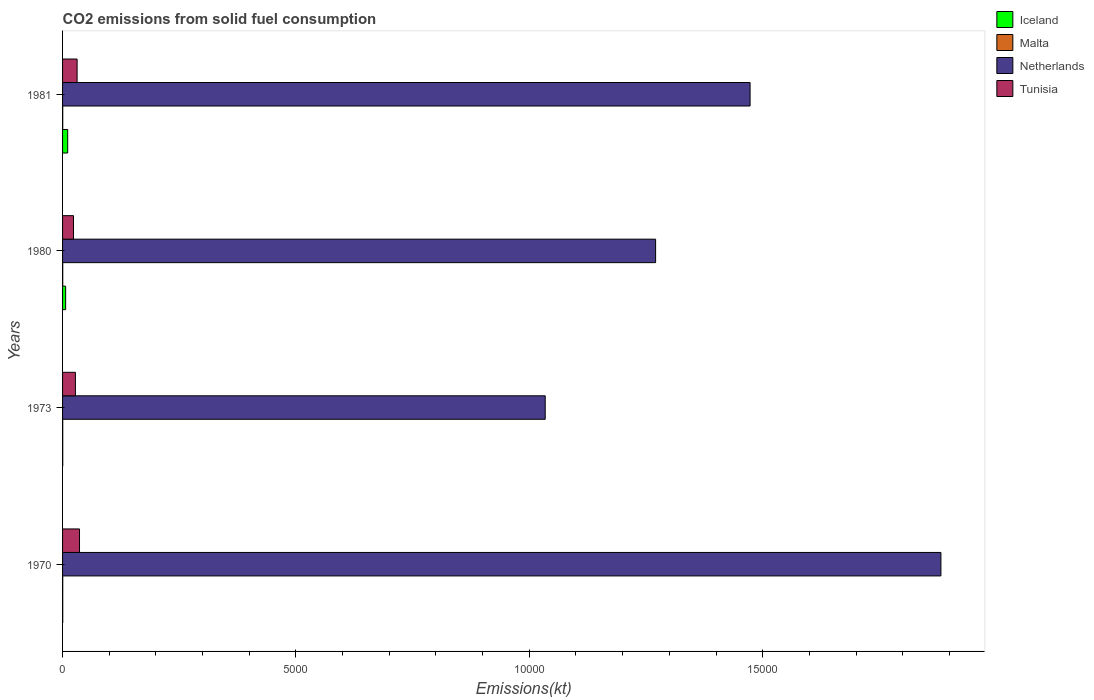How many different coloured bars are there?
Give a very brief answer. 4. Are the number of bars on each tick of the Y-axis equal?
Provide a short and direct response. Yes. How many bars are there on the 4th tick from the top?
Your answer should be very brief. 4. What is the label of the 4th group of bars from the top?
Your answer should be very brief. 1970. In how many cases, is the number of bars for a given year not equal to the number of legend labels?
Ensure brevity in your answer.  0. What is the amount of CO2 emitted in Netherlands in 1973?
Provide a succinct answer. 1.03e+04. Across all years, what is the maximum amount of CO2 emitted in Netherlands?
Make the answer very short. 1.88e+04. Across all years, what is the minimum amount of CO2 emitted in Tunisia?
Your answer should be compact. 234.69. What is the total amount of CO2 emitted in Netherlands in the graph?
Provide a short and direct response. 5.66e+04. What is the difference between the amount of CO2 emitted in Malta in 1970 and the amount of CO2 emitted in Netherlands in 1973?
Offer a very short reply. -1.03e+04. What is the average amount of CO2 emitted in Netherlands per year?
Provide a succinct answer. 1.41e+04. In the year 1980, what is the difference between the amount of CO2 emitted in Iceland and amount of CO2 emitted in Malta?
Provide a succinct answer. 62.34. In how many years, is the amount of CO2 emitted in Iceland greater than 7000 kt?
Provide a short and direct response. 0. Is the difference between the amount of CO2 emitted in Iceland in 1980 and 1981 greater than the difference between the amount of CO2 emitted in Malta in 1980 and 1981?
Offer a terse response. No. What is the difference between the highest and the second highest amount of CO2 emitted in Tunisia?
Ensure brevity in your answer.  51.34. What is the difference between the highest and the lowest amount of CO2 emitted in Netherlands?
Offer a very short reply. 8478.1. Is it the case that in every year, the sum of the amount of CO2 emitted in Netherlands and amount of CO2 emitted in Malta is greater than the sum of amount of CO2 emitted in Tunisia and amount of CO2 emitted in Iceland?
Your response must be concise. Yes. What does the 1st bar from the top in 1981 represents?
Keep it short and to the point. Tunisia. What does the 3rd bar from the bottom in 1980 represents?
Offer a very short reply. Netherlands. Is it the case that in every year, the sum of the amount of CO2 emitted in Iceland and amount of CO2 emitted in Malta is greater than the amount of CO2 emitted in Netherlands?
Offer a very short reply. No. How many bars are there?
Provide a succinct answer. 16. How many years are there in the graph?
Provide a short and direct response. 4. Are the values on the major ticks of X-axis written in scientific E-notation?
Your answer should be compact. No. Does the graph contain any zero values?
Your answer should be compact. No. How many legend labels are there?
Provide a short and direct response. 4. What is the title of the graph?
Ensure brevity in your answer.  CO2 emissions from solid fuel consumption. Does "Guinea-Bissau" appear as one of the legend labels in the graph?
Your answer should be very brief. No. What is the label or title of the X-axis?
Your response must be concise. Emissions(kt). What is the Emissions(kt) in Iceland in 1970?
Keep it short and to the point. 3.67. What is the Emissions(kt) of Malta in 1970?
Provide a short and direct response. 3.67. What is the Emissions(kt) of Netherlands in 1970?
Offer a very short reply. 1.88e+04. What is the Emissions(kt) in Tunisia in 1970?
Give a very brief answer. 363.03. What is the Emissions(kt) in Iceland in 1973?
Provide a succinct answer. 3.67. What is the Emissions(kt) in Malta in 1973?
Give a very brief answer. 3.67. What is the Emissions(kt) of Netherlands in 1973?
Give a very brief answer. 1.03e+04. What is the Emissions(kt) of Tunisia in 1973?
Your response must be concise. 275.02. What is the Emissions(kt) of Iceland in 1980?
Offer a very short reply. 66.01. What is the Emissions(kt) of Malta in 1980?
Offer a very short reply. 3.67. What is the Emissions(kt) in Netherlands in 1980?
Provide a short and direct response. 1.27e+04. What is the Emissions(kt) of Tunisia in 1980?
Give a very brief answer. 234.69. What is the Emissions(kt) of Iceland in 1981?
Your response must be concise. 110.01. What is the Emissions(kt) of Malta in 1981?
Ensure brevity in your answer.  3.67. What is the Emissions(kt) in Netherlands in 1981?
Provide a short and direct response. 1.47e+04. What is the Emissions(kt) in Tunisia in 1981?
Ensure brevity in your answer.  311.69. Across all years, what is the maximum Emissions(kt) of Iceland?
Your answer should be compact. 110.01. Across all years, what is the maximum Emissions(kt) in Malta?
Provide a succinct answer. 3.67. Across all years, what is the maximum Emissions(kt) of Netherlands?
Offer a very short reply. 1.88e+04. Across all years, what is the maximum Emissions(kt) in Tunisia?
Keep it short and to the point. 363.03. Across all years, what is the minimum Emissions(kt) of Iceland?
Your response must be concise. 3.67. Across all years, what is the minimum Emissions(kt) of Malta?
Keep it short and to the point. 3.67. Across all years, what is the minimum Emissions(kt) of Netherlands?
Offer a terse response. 1.03e+04. Across all years, what is the minimum Emissions(kt) of Tunisia?
Keep it short and to the point. 234.69. What is the total Emissions(kt) of Iceland in the graph?
Provide a short and direct response. 183.35. What is the total Emissions(kt) of Malta in the graph?
Offer a very short reply. 14.67. What is the total Emissions(kt) of Netherlands in the graph?
Offer a very short reply. 5.66e+04. What is the total Emissions(kt) of Tunisia in the graph?
Your answer should be compact. 1184.44. What is the difference between the Emissions(kt) in Iceland in 1970 and that in 1973?
Make the answer very short. 0. What is the difference between the Emissions(kt) in Malta in 1970 and that in 1973?
Offer a very short reply. 0. What is the difference between the Emissions(kt) of Netherlands in 1970 and that in 1973?
Provide a short and direct response. 8478.1. What is the difference between the Emissions(kt) of Tunisia in 1970 and that in 1973?
Make the answer very short. 88.01. What is the difference between the Emissions(kt) of Iceland in 1970 and that in 1980?
Offer a very short reply. -62.34. What is the difference between the Emissions(kt) in Netherlands in 1970 and that in 1980?
Keep it short and to the point. 6112.89. What is the difference between the Emissions(kt) in Tunisia in 1970 and that in 1980?
Your response must be concise. 128.34. What is the difference between the Emissions(kt) of Iceland in 1970 and that in 1981?
Provide a short and direct response. -106.34. What is the difference between the Emissions(kt) in Malta in 1970 and that in 1981?
Give a very brief answer. 0. What is the difference between the Emissions(kt) in Netherlands in 1970 and that in 1981?
Ensure brevity in your answer.  4088.7. What is the difference between the Emissions(kt) in Tunisia in 1970 and that in 1981?
Provide a succinct answer. 51.34. What is the difference between the Emissions(kt) of Iceland in 1973 and that in 1980?
Give a very brief answer. -62.34. What is the difference between the Emissions(kt) in Malta in 1973 and that in 1980?
Your answer should be compact. 0. What is the difference between the Emissions(kt) in Netherlands in 1973 and that in 1980?
Keep it short and to the point. -2365.22. What is the difference between the Emissions(kt) in Tunisia in 1973 and that in 1980?
Provide a short and direct response. 40.34. What is the difference between the Emissions(kt) of Iceland in 1973 and that in 1981?
Offer a terse response. -106.34. What is the difference between the Emissions(kt) in Netherlands in 1973 and that in 1981?
Offer a very short reply. -4389.4. What is the difference between the Emissions(kt) in Tunisia in 1973 and that in 1981?
Provide a succinct answer. -36.67. What is the difference between the Emissions(kt) in Iceland in 1980 and that in 1981?
Your response must be concise. -44. What is the difference between the Emissions(kt) in Malta in 1980 and that in 1981?
Give a very brief answer. 0. What is the difference between the Emissions(kt) of Netherlands in 1980 and that in 1981?
Your answer should be very brief. -2024.18. What is the difference between the Emissions(kt) of Tunisia in 1980 and that in 1981?
Offer a very short reply. -77.01. What is the difference between the Emissions(kt) of Iceland in 1970 and the Emissions(kt) of Malta in 1973?
Give a very brief answer. 0. What is the difference between the Emissions(kt) of Iceland in 1970 and the Emissions(kt) of Netherlands in 1973?
Offer a terse response. -1.03e+04. What is the difference between the Emissions(kt) in Iceland in 1970 and the Emissions(kt) in Tunisia in 1973?
Provide a short and direct response. -271.36. What is the difference between the Emissions(kt) of Malta in 1970 and the Emissions(kt) of Netherlands in 1973?
Ensure brevity in your answer.  -1.03e+04. What is the difference between the Emissions(kt) in Malta in 1970 and the Emissions(kt) in Tunisia in 1973?
Provide a short and direct response. -271.36. What is the difference between the Emissions(kt) in Netherlands in 1970 and the Emissions(kt) in Tunisia in 1973?
Your response must be concise. 1.85e+04. What is the difference between the Emissions(kt) in Iceland in 1970 and the Emissions(kt) in Malta in 1980?
Offer a terse response. 0. What is the difference between the Emissions(kt) of Iceland in 1970 and the Emissions(kt) of Netherlands in 1980?
Your answer should be very brief. -1.27e+04. What is the difference between the Emissions(kt) in Iceland in 1970 and the Emissions(kt) in Tunisia in 1980?
Your answer should be compact. -231.02. What is the difference between the Emissions(kt) in Malta in 1970 and the Emissions(kt) in Netherlands in 1980?
Give a very brief answer. -1.27e+04. What is the difference between the Emissions(kt) of Malta in 1970 and the Emissions(kt) of Tunisia in 1980?
Your answer should be compact. -231.02. What is the difference between the Emissions(kt) in Netherlands in 1970 and the Emissions(kt) in Tunisia in 1980?
Ensure brevity in your answer.  1.86e+04. What is the difference between the Emissions(kt) of Iceland in 1970 and the Emissions(kt) of Malta in 1981?
Ensure brevity in your answer.  0. What is the difference between the Emissions(kt) in Iceland in 1970 and the Emissions(kt) in Netherlands in 1981?
Make the answer very short. -1.47e+04. What is the difference between the Emissions(kt) in Iceland in 1970 and the Emissions(kt) in Tunisia in 1981?
Ensure brevity in your answer.  -308.03. What is the difference between the Emissions(kt) of Malta in 1970 and the Emissions(kt) of Netherlands in 1981?
Your response must be concise. -1.47e+04. What is the difference between the Emissions(kt) of Malta in 1970 and the Emissions(kt) of Tunisia in 1981?
Offer a very short reply. -308.03. What is the difference between the Emissions(kt) of Netherlands in 1970 and the Emissions(kt) of Tunisia in 1981?
Your answer should be compact. 1.85e+04. What is the difference between the Emissions(kt) in Iceland in 1973 and the Emissions(kt) in Netherlands in 1980?
Provide a short and direct response. -1.27e+04. What is the difference between the Emissions(kt) of Iceland in 1973 and the Emissions(kt) of Tunisia in 1980?
Provide a succinct answer. -231.02. What is the difference between the Emissions(kt) of Malta in 1973 and the Emissions(kt) of Netherlands in 1980?
Give a very brief answer. -1.27e+04. What is the difference between the Emissions(kt) in Malta in 1973 and the Emissions(kt) in Tunisia in 1980?
Your answer should be compact. -231.02. What is the difference between the Emissions(kt) in Netherlands in 1973 and the Emissions(kt) in Tunisia in 1980?
Ensure brevity in your answer.  1.01e+04. What is the difference between the Emissions(kt) of Iceland in 1973 and the Emissions(kt) of Netherlands in 1981?
Give a very brief answer. -1.47e+04. What is the difference between the Emissions(kt) in Iceland in 1973 and the Emissions(kt) in Tunisia in 1981?
Keep it short and to the point. -308.03. What is the difference between the Emissions(kt) of Malta in 1973 and the Emissions(kt) of Netherlands in 1981?
Your answer should be very brief. -1.47e+04. What is the difference between the Emissions(kt) in Malta in 1973 and the Emissions(kt) in Tunisia in 1981?
Your answer should be very brief. -308.03. What is the difference between the Emissions(kt) in Netherlands in 1973 and the Emissions(kt) in Tunisia in 1981?
Provide a succinct answer. 1.00e+04. What is the difference between the Emissions(kt) of Iceland in 1980 and the Emissions(kt) of Malta in 1981?
Make the answer very short. 62.34. What is the difference between the Emissions(kt) in Iceland in 1980 and the Emissions(kt) in Netherlands in 1981?
Make the answer very short. -1.47e+04. What is the difference between the Emissions(kt) of Iceland in 1980 and the Emissions(kt) of Tunisia in 1981?
Your response must be concise. -245.69. What is the difference between the Emissions(kt) of Malta in 1980 and the Emissions(kt) of Netherlands in 1981?
Keep it short and to the point. -1.47e+04. What is the difference between the Emissions(kt) in Malta in 1980 and the Emissions(kt) in Tunisia in 1981?
Offer a terse response. -308.03. What is the difference between the Emissions(kt) of Netherlands in 1980 and the Emissions(kt) of Tunisia in 1981?
Offer a terse response. 1.24e+04. What is the average Emissions(kt) of Iceland per year?
Keep it short and to the point. 45.84. What is the average Emissions(kt) in Malta per year?
Your answer should be very brief. 3.67. What is the average Emissions(kt) of Netherlands per year?
Offer a terse response. 1.41e+04. What is the average Emissions(kt) of Tunisia per year?
Provide a short and direct response. 296.11. In the year 1970, what is the difference between the Emissions(kt) of Iceland and Emissions(kt) of Netherlands?
Give a very brief answer. -1.88e+04. In the year 1970, what is the difference between the Emissions(kt) in Iceland and Emissions(kt) in Tunisia?
Offer a very short reply. -359.37. In the year 1970, what is the difference between the Emissions(kt) of Malta and Emissions(kt) of Netherlands?
Give a very brief answer. -1.88e+04. In the year 1970, what is the difference between the Emissions(kt) of Malta and Emissions(kt) of Tunisia?
Provide a succinct answer. -359.37. In the year 1970, what is the difference between the Emissions(kt) of Netherlands and Emissions(kt) of Tunisia?
Give a very brief answer. 1.85e+04. In the year 1973, what is the difference between the Emissions(kt) in Iceland and Emissions(kt) in Malta?
Make the answer very short. 0. In the year 1973, what is the difference between the Emissions(kt) of Iceland and Emissions(kt) of Netherlands?
Your answer should be compact. -1.03e+04. In the year 1973, what is the difference between the Emissions(kt) in Iceland and Emissions(kt) in Tunisia?
Your response must be concise. -271.36. In the year 1973, what is the difference between the Emissions(kt) of Malta and Emissions(kt) of Netherlands?
Give a very brief answer. -1.03e+04. In the year 1973, what is the difference between the Emissions(kt) in Malta and Emissions(kt) in Tunisia?
Your answer should be very brief. -271.36. In the year 1973, what is the difference between the Emissions(kt) in Netherlands and Emissions(kt) in Tunisia?
Your response must be concise. 1.01e+04. In the year 1980, what is the difference between the Emissions(kt) in Iceland and Emissions(kt) in Malta?
Offer a very short reply. 62.34. In the year 1980, what is the difference between the Emissions(kt) in Iceland and Emissions(kt) in Netherlands?
Provide a succinct answer. -1.26e+04. In the year 1980, what is the difference between the Emissions(kt) of Iceland and Emissions(kt) of Tunisia?
Make the answer very short. -168.68. In the year 1980, what is the difference between the Emissions(kt) in Malta and Emissions(kt) in Netherlands?
Keep it short and to the point. -1.27e+04. In the year 1980, what is the difference between the Emissions(kt) in Malta and Emissions(kt) in Tunisia?
Keep it short and to the point. -231.02. In the year 1980, what is the difference between the Emissions(kt) in Netherlands and Emissions(kt) in Tunisia?
Your answer should be compact. 1.25e+04. In the year 1981, what is the difference between the Emissions(kt) in Iceland and Emissions(kt) in Malta?
Ensure brevity in your answer.  106.34. In the year 1981, what is the difference between the Emissions(kt) in Iceland and Emissions(kt) in Netherlands?
Give a very brief answer. -1.46e+04. In the year 1981, what is the difference between the Emissions(kt) of Iceland and Emissions(kt) of Tunisia?
Your answer should be very brief. -201.69. In the year 1981, what is the difference between the Emissions(kt) of Malta and Emissions(kt) of Netherlands?
Your answer should be very brief. -1.47e+04. In the year 1981, what is the difference between the Emissions(kt) of Malta and Emissions(kt) of Tunisia?
Provide a short and direct response. -308.03. In the year 1981, what is the difference between the Emissions(kt) in Netherlands and Emissions(kt) in Tunisia?
Ensure brevity in your answer.  1.44e+04. What is the ratio of the Emissions(kt) of Malta in 1970 to that in 1973?
Your response must be concise. 1. What is the ratio of the Emissions(kt) in Netherlands in 1970 to that in 1973?
Ensure brevity in your answer.  1.82. What is the ratio of the Emissions(kt) in Tunisia in 1970 to that in 1973?
Your answer should be compact. 1.32. What is the ratio of the Emissions(kt) in Iceland in 1970 to that in 1980?
Ensure brevity in your answer.  0.06. What is the ratio of the Emissions(kt) in Malta in 1970 to that in 1980?
Offer a very short reply. 1. What is the ratio of the Emissions(kt) in Netherlands in 1970 to that in 1980?
Keep it short and to the point. 1.48. What is the ratio of the Emissions(kt) of Tunisia in 1970 to that in 1980?
Provide a short and direct response. 1.55. What is the ratio of the Emissions(kt) of Iceland in 1970 to that in 1981?
Offer a very short reply. 0.03. What is the ratio of the Emissions(kt) of Netherlands in 1970 to that in 1981?
Your answer should be compact. 1.28. What is the ratio of the Emissions(kt) in Tunisia in 1970 to that in 1981?
Your answer should be compact. 1.16. What is the ratio of the Emissions(kt) of Iceland in 1973 to that in 1980?
Keep it short and to the point. 0.06. What is the ratio of the Emissions(kt) in Malta in 1973 to that in 1980?
Your response must be concise. 1. What is the ratio of the Emissions(kt) of Netherlands in 1973 to that in 1980?
Provide a succinct answer. 0.81. What is the ratio of the Emissions(kt) of Tunisia in 1973 to that in 1980?
Keep it short and to the point. 1.17. What is the ratio of the Emissions(kt) of Iceland in 1973 to that in 1981?
Your response must be concise. 0.03. What is the ratio of the Emissions(kt) of Malta in 1973 to that in 1981?
Provide a short and direct response. 1. What is the ratio of the Emissions(kt) of Netherlands in 1973 to that in 1981?
Offer a very short reply. 0.7. What is the ratio of the Emissions(kt) in Tunisia in 1973 to that in 1981?
Offer a terse response. 0.88. What is the ratio of the Emissions(kt) in Iceland in 1980 to that in 1981?
Provide a short and direct response. 0.6. What is the ratio of the Emissions(kt) of Netherlands in 1980 to that in 1981?
Give a very brief answer. 0.86. What is the ratio of the Emissions(kt) of Tunisia in 1980 to that in 1981?
Make the answer very short. 0.75. What is the difference between the highest and the second highest Emissions(kt) in Iceland?
Your response must be concise. 44. What is the difference between the highest and the second highest Emissions(kt) of Malta?
Make the answer very short. 0. What is the difference between the highest and the second highest Emissions(kt) of Netherlands?
Give a very brief answer. 4088.7. What is the difference between the highest and the second highest Emissions(kt) of Tunisia?
Keep it short and to the point. 51.34. What is the difference between the highest and the lowest Emissions(kt) of Iceland?
Your answer should be very brief. 106.34. What is the difference between the highest and the lowest Emissions(kt) in Malta?
Keep it short and to the point. 0. What is the difference between the highest and the lowest Emissions(kt) of Netherlands?
Keep it short and to the point. 8478.1. What is the difference between the highest and the lowest Emissions(kt) in Tunisia?
Offer a very short reply. 128.34. 